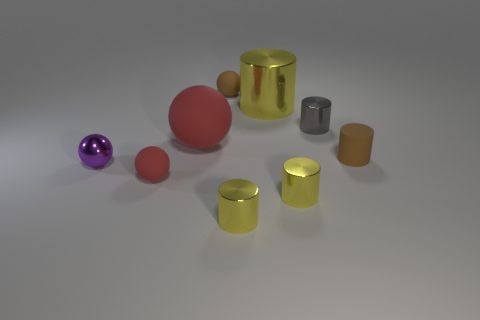Subtract all red spheres. How many yellow cylinders are left? 3 Subtract all gray cylinders. How many cylinders are left? 4 Subtract all tiny gray cylinders. How many cylinders are left? 4 Subtract all cyan cylinders. Subtract all gray balls. How many cylinders are left? 5 Subtract all balls. How many objects are left? 5 Subtract all brown matte spheres. Subtract all big red matte objects. How many objects are left? 7 Add 5 tiny yellow objects. How many tiny yellow objects are left? 7 Add 8 small yellow objects. How many small yellow objects exist? 10 Subtract 0 brown blocks. How many objects are left? 9 